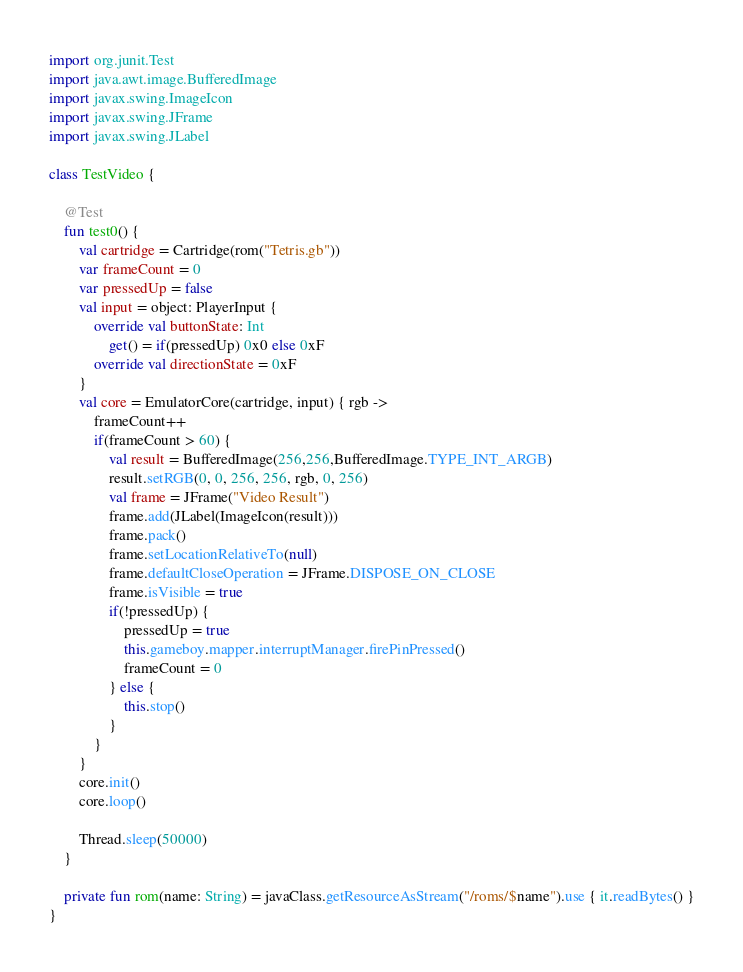<code> <loc_0><loc_0><loc_500><loc_500><_Kotlin_>import org.junit.Test
import java.awt.image.BufferedImage
import javax.swing.ImageIcon
import javax.swing.JFrame
import javax.swing.JLabel

class TestVideo {

    @Test
    fun test0() {
        val cartridge = Cartridge(rom("Tetris.gb"))
        var frameCount = 0
        var pressedUp = false
        val input = object: PlayerInput {
            override val buttonState: Int
                get() = if(pressedUp) 0x0 else 0xF
            override val directionState = 0xF
        }
        val core = EmulatorCore(cartridge, input) { rgb ->
            frameCount++
            if(frameCount > 60) {
                val result = BufferedImage(256,256,BufferedImage.TYPE_INT_ARGB)
                result.setRGB(0, 0, 256, 256, rgb, 0, 256)
                val frame = JFrame("Video Result")
                frame.add(JLabel(ImageIcon(result)))
                frame.pack()
                frame.setLocationRelativeTo(null)
                frame.defaultCloseOperation = JFrame.DISPOSE_ON_CLOSE
                frame.isVisible = true
                if(!pressedUp) {
                    pressedUp = true
                    this.gameboy.mapper.interruptManager.firePinPressed()
                    frameCount = 0
                } else {
                    this.stop()
                }
            }
        }
        core.init()
        core.loop()

        Thread.sleep(50000)
    }

    private fun rom(name: String) = javaClass.getResourceAsStream("/roms/$name").use { it.readBytes() }
}</code> 